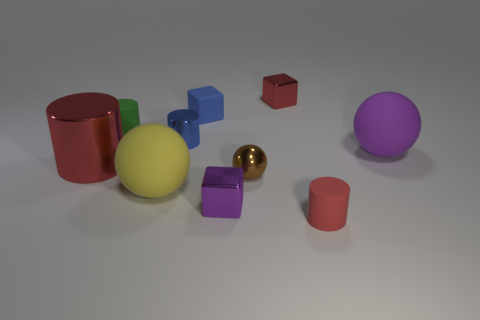What material is the other big red thing that is the same shape as the red matte object?
Your answer should be compact. Metal. What is the material of the cylinder that is the same size as the yellow object?
Offer a very short reply. Metal. Is there a small green cylinder that has the same material as the tiny red cylinder?
Make the answer very short. Yes. What is the color of the small rubber cylinder behind the big matte thing behind the tiny brown ball to the right of the big shiny thing?
Your answer should be compact. Green. There is a large rubber thing right of the purple metallic block; does it have the same color as the metallic cube on the left side of the small red shiny block?
Offer a terse response. Yes. Are there any other things that have the same color as the tiny matte cube?
Provide a short and direct response. Yes. Are there fewer small metal cylinders right of the small red matte cylinder than small red matte cylinders?
Your answer should be very brief. Yes. What number of brown metal spheres are there?
Your response must be concise. 1. Does the large red shiny object have the same shape as the tiny shiny thing that is behind the tiny green thing?
Ensure brevity in your answer.  No. Are there fewer red objects right of the large purple thing than things that are behind the rubber cube?
Keep it short and to the point. Yes. 